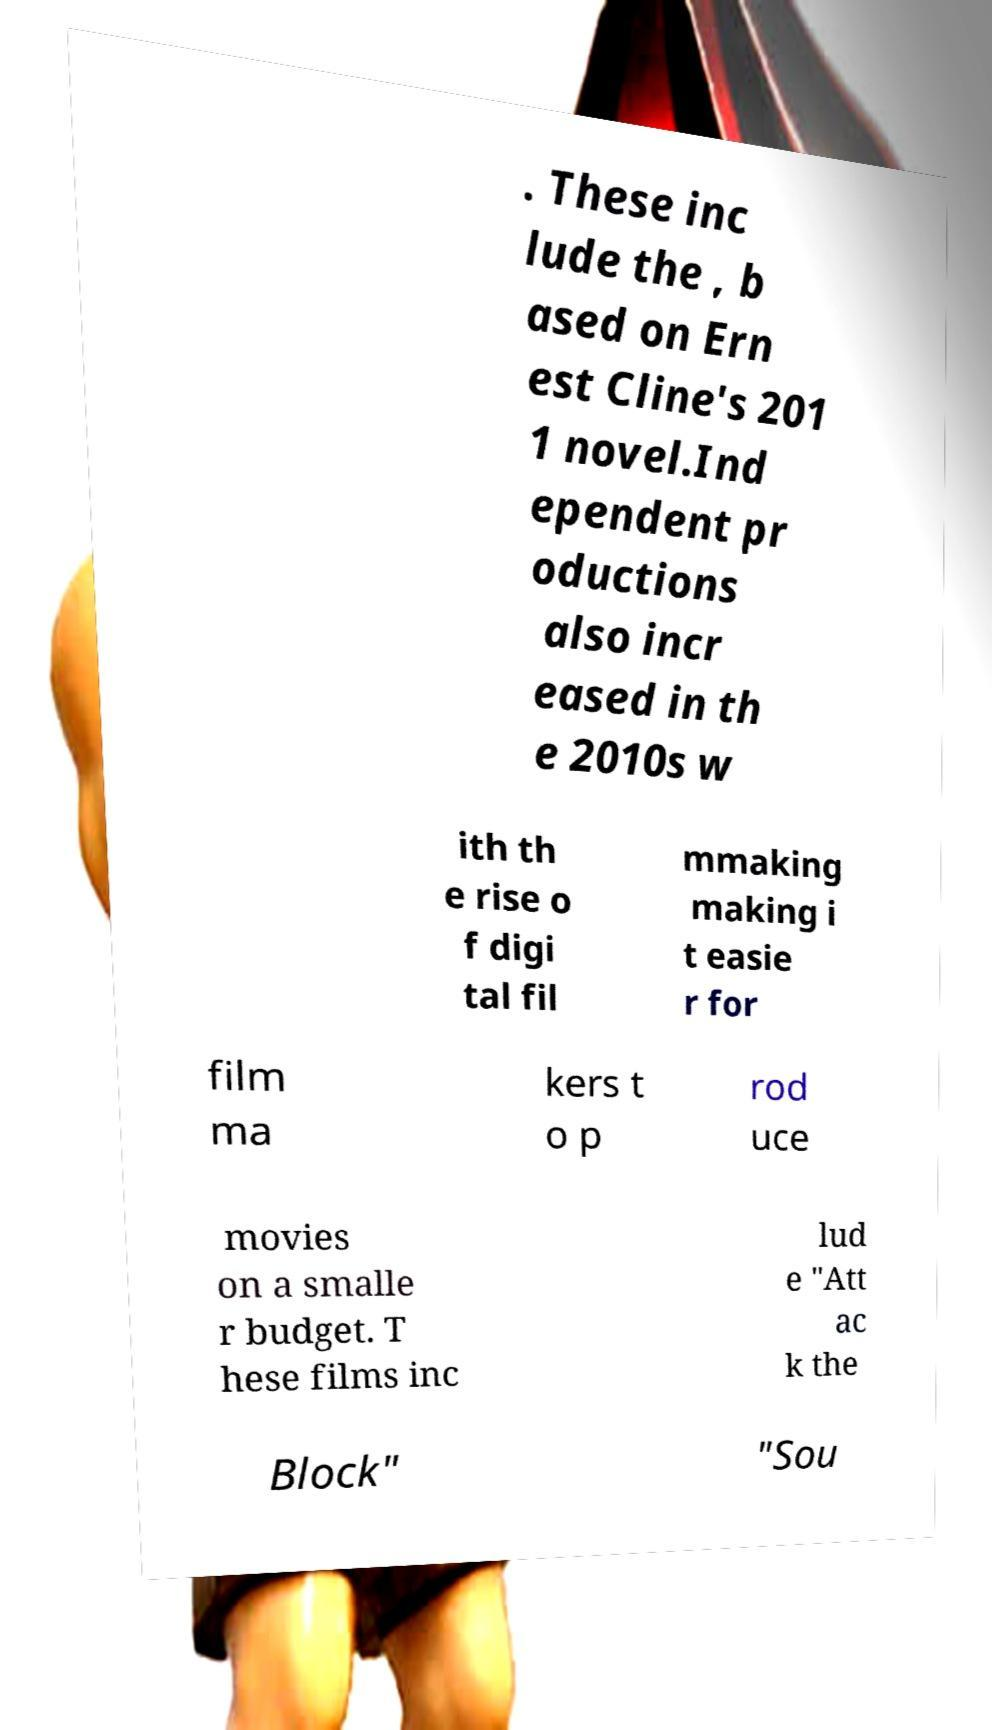For documentation purposes, I need the text within this image transcribed. Could you provide that? . These inc lude the , b ased on Ern est Cline's 201 1 novel.Ind ependent pr oductions also incr eased in th e 2010s w ith th e rise o f digi tal fil mmaking making i t easie r for film ma kers t o p rod uce movies on a smalle r budget. T hese films inc lud e "Att ac k the Block" "Sou 